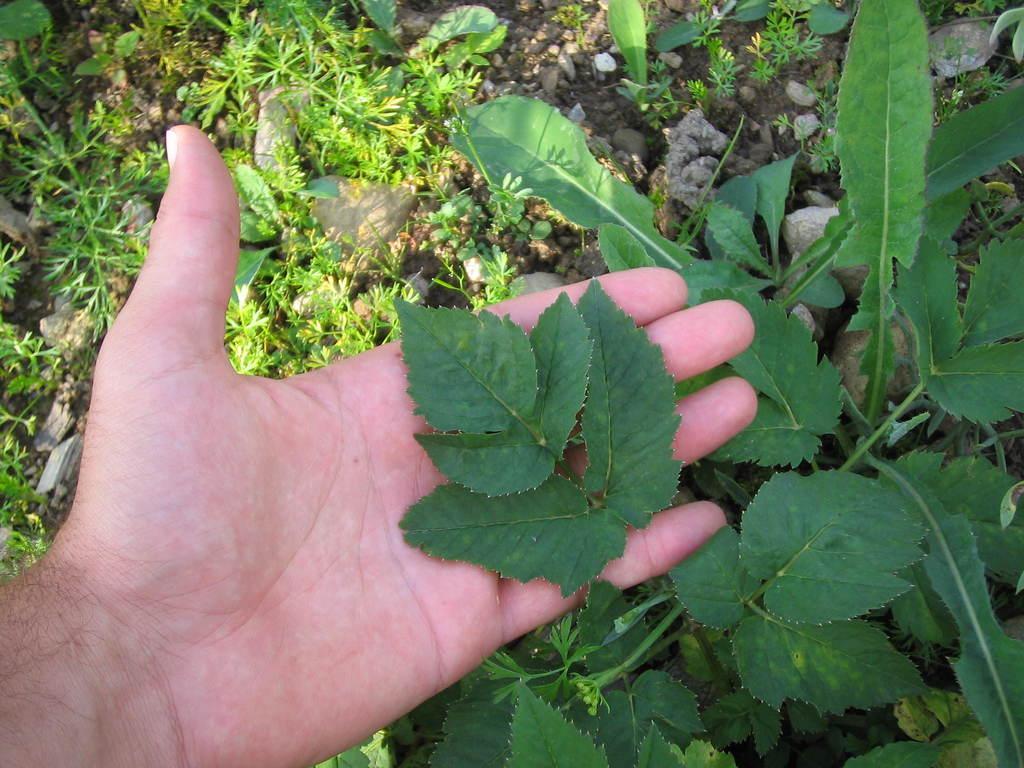How would you summarize this image in a sentence or two? In this picture we can see a leaf on a person hand and in the background we can see stones, plant on the ground. 